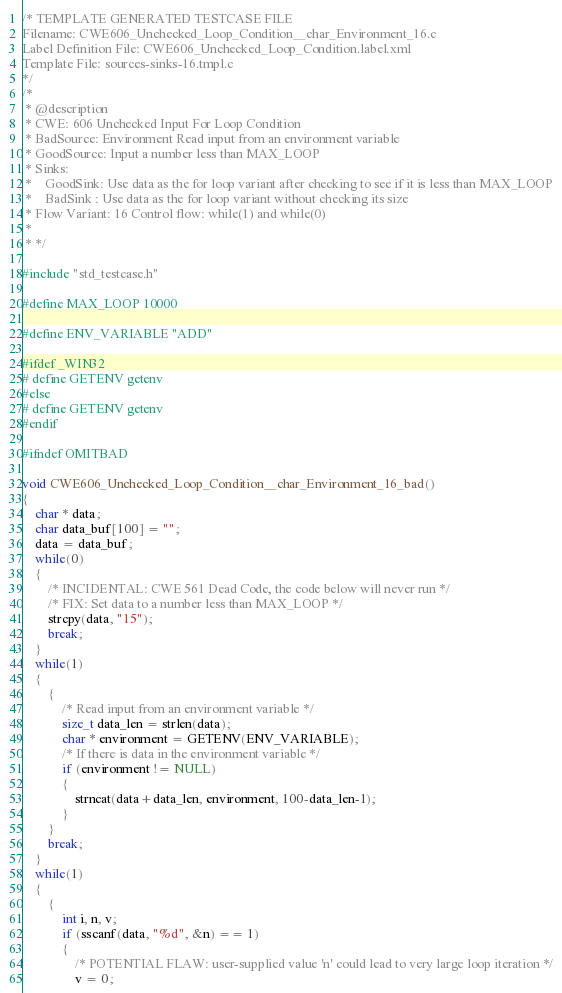<code> <loc_0><loc_0><loc_500><loc_500><_C_>/* TEMPLATE GENERATED TESTCASE FILE
Filename: CWE606_Unchecked_Loop_Condition__char_Environment_16.c
Label Definition File: CWE606_Unchecked_Loop_Condition.label.xml
Template File: sources-sinks-16.tmpl.c
*/
/*
 * @description
 * CWE: 606 Unchecked Input For Loop Condition
 * BadSource: Environment Read input from an environment variable
 * GoodSource: Input a number less than MAX_LOOP
 * Sinks:
 *    GoodSink: Use data as the for loop variant after checking to see if it is less than MAX_LOOP
 *    BadSink : Use data as the for loop variant without checking its size
 * Flow Variant: 16 Control flow: while(1) and while(0)
 *
 * */

#include "std_testcase.h"

#define MAX_LOOP 10000

#define ENV_VARIABLE "ADD"

#ifdef _WIN32
# define GETENV getenv
#else
# define GETENV getenv
#endif

#ifndef OMITBAD

void CWE606_Unchecked_Loop_Condition__char_Environment_16_bad()
{
    char * data;
    char data_buf[100] = "";
    data = data_buf;
    while(0)
    {
        /* INCIDENTAL: CWE 561 Dead Code, the code below will never run */
        /* FIX: Set data to a number less than MAX_LOOP */
        strcpy(data, "15");
        break;
    }
    while(1)
    {
        {
            /* Read input from an environment variable */
            size_t data_len = strlen(data);
            char * environment = GETENV(ENV_VARIABLE);
            /* If there is data in the environment variable */
            if (environment != NULL)
            {
                strncat(data+data_len, environment, 100-data_len-1);
            }
        }
        break;
    }
    while(1)
    {
        {
            int i, n, v;
            if (sscanf(data, "%d", &n) == 1)
            {
                /* POTENTIAL FLAW: user-supplied value 'n' could lead to very large loop iteration */
                v = 0;</code> 